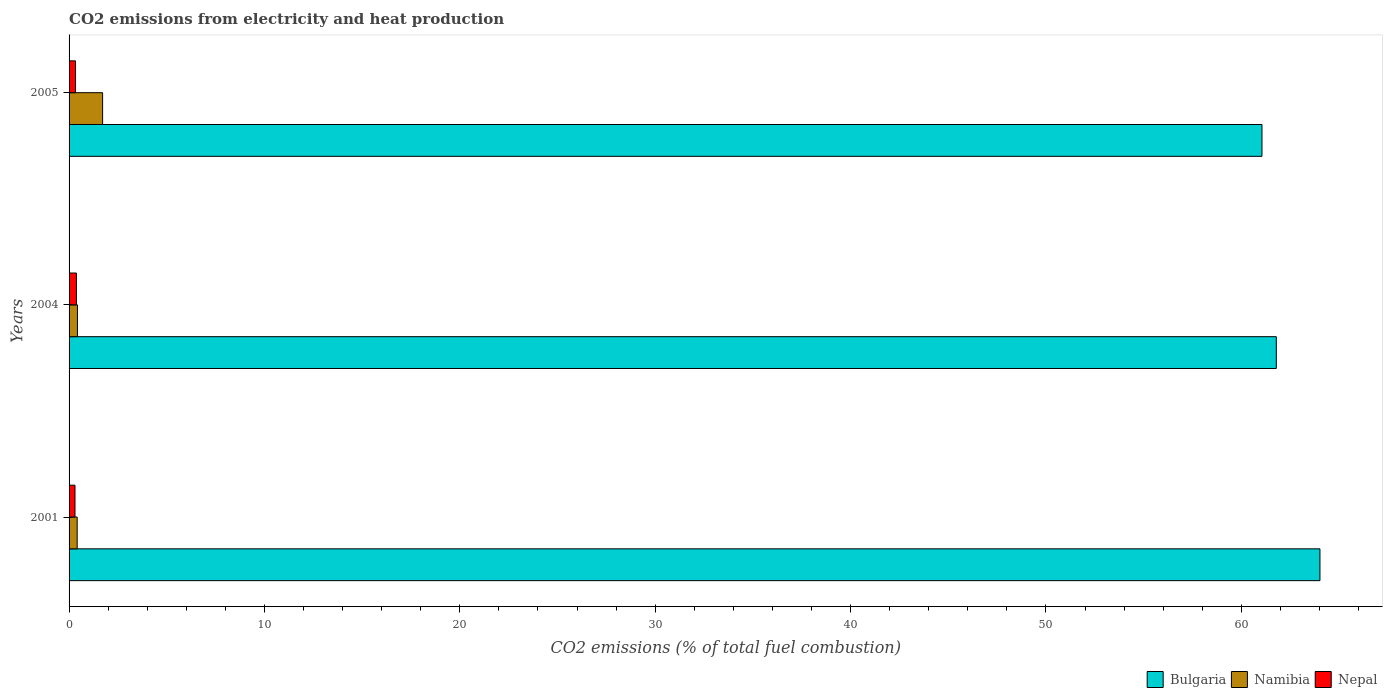How many bars are there on the 3rd tick from the top?
Your response must be concise. 3. What is the label of the 1st group of bars from the top?
Provide a succinct answer. 2005. In how many cases, is the number of bars for a given year not equal to the number of legend labels?
Offer a terse response. 0. What is the amount of CO2 emitted in Nepal in 2001?
Your response must be concise. 0.3. Across all years, what is the maximum amount of CO2 emitted in Nepal?
Your response must be concise. 0.38. Across all years, what is the minimum amount of CO2 emitted in Namibia?
Your response must be concise. 0.41. In which year was the amount of CO2 emitted in Bulgaria maximum?
Ensure brevity in your answer.  2001. In which year was the amount of CO2 emitted in Namibia minimum?
Your answer should be very brief. 2001. What is the total amount of CO2 emitted in Bulgaria in the graph?
Your answer should be very brief. 186.88. What is the difference between the amount of CO2 emitted in Bulgaria in 2001 and that in 2004?
Make the answer very short. 2.23. What is the difference between the amount of CO2 emitted in Namibia in 2004 and the amount of CO2 emitted in Bulgaria in 2001?
Give a very brief answer. -63.6. What is the average amount of CO2 emitted in Nepal per year?
Your answer should be very brief. 0.34. In the year 2005, what is the difference between the amount of CO2 emitted in Namibia and amount of CO2 emitted in Nepal?
Keep it short and to the point. 1.39. What is the ratio of the amount of CO2 emitted in Bulgaria in 2001 to that in 2004?
Your answer should be very brief. 1.04. What is the difference between the highest and the second highest amount of CO2 emitted in Namibia?
Your response must be concise. 1.29. What is the difference between the highest and the lowest amount of CO2 emitted in Bulgaria?
Your response must be concise. 2.97. In how many years, is the amount of CO2 emitted in Bulgaria greater than the average amount of CO2 emitted in Bulgaria taken over all years?
Keep it short and to the point. 1. How many bars are there?
Ensure brevity in your answer.  9. How many years are there in the graph?
Your answer should be compact. 3. Are the values on the major ticks of X-axis written in scientific E-notation?
Provide a short and direct response. No. Does the graph contain any zero values?
Your response must be concise. No. How many legend labels are there?
Your answer should be compact. 3. What is the title of the graph?
Your answer should be very brief. CO2 emissions from electricity and heat production. Does "Antigua and Barbuda" appear as one of the legend labels in the graph?
Offer a terse response. No. What is the label or title of the X-axis?
Provide a succinct answer. CO2 emissions (% of total fuel combustion). What is the label or title of the Y-axis?
Give a very brief answer. Years. What is the CO2 emissions (% of total fuel combustion) in Bulgaria in 2001?
Offer a very short reply. 64.03. What is the CO2 emissions (% of total fuel combustion) of Namibia in 2001?
Give a very brief answer. 0.41. What is the CO2 emissions (% of total fuel combustion) of Nepal in 2001?
Offer a very short reply. 0.3. What is the CO2 emissions (% of total fuel combustion) in Bulgaria in 2004?
Ensure brevity in your answer.  61.79. What is the CO2 emissions (% of total fuel combustion) of Namibia in 2004?
Give a very brief answer. 0.43. What is the CO2 emissions (% of total fuel combustion) of Nepal in 2004?
Your answer should be compact. 0.38. What is the CO2 emissions (% of total fuel combustion) of Bulgaria in 2005?
Your response must be concise. 61.06. What is the CO2 emissions (% of total fuel combustion) of Namibia in 2005?
Make the answer very short. 1.72. What is the CO2 emissions (% of total fuel combustion) in Nepal in 2005?
Offer a terse response. 0.33. Across all years, what is the maximum CO2 emissions (% of total fuel combustion) in Bulgaria?
Your answer should be very brief. 64.03. Across all years, what is the maximum CO2 emissions (% of total fuel combustion) in Namibia?
Your answer should be very brief. 1.72. Across all years, what is the maximum CO2 emissions (% of total fuel combustion) in Nepal?
Keep it short and to the point. 0.38. Across all years, what is the minimum CO2 emissions (% of total fuel combustion) of Bulgaria?
Provide a succinct answer. 61.06. Across all years, what is the minimum CO2 emissions (% of total fuel combustion) of Namibia?
Your response must be concise. 0.41. Across all years, what is the minimum CO2 emissions (% of total fuel combustion) in Nepal?
Provide a short and direct response. 0.3. What is the total CO2 emissions (% of total fuel combustion) in Bulgaria in the graph?
Keep it short and to the point. 186.88. What is the total CO2 emissions (% of total fuel combustion) of Namibia in the graph?
Provide a short and direct response. 2.56. What is the difference between the CO2 emissions (% of total fuel combustion) in Bulgaria in 2001 and that in 2004?
Your response must be concise. 2.23. What is the difference between the CO2 emissions (% of total fuel combustion) in Namibia in 2001 and that in 2004?
Provide a succinct answer. -0.01. What is the difference between the CO2 emissions (% of total fuel combustion) in Nepal in 2001 and that in 2004?
Keep it short and to the point. -0.07. What is the difference between the CO2 emissions (% of total fuel combustion) of Bulgaria in 2001 and that in 2005?
Offer a very short reply. 2.97. What is the difference between the CO2 emissions (% of total fuel combustion) in Namibia in 2001 and that in 2005?
Make the answer very short. -1.3. What is the difference between the CO2 emissions (% of total fuel combustion) in Nepal in 2001 and that in 2005?
Your answer should be compact. -0.03. What is the difference between the CO2 emissions (% of total fuel combustion) of Bulgaria in 2004 and that in 2005?
Make the answer very short. 0.73. What is the difference between the CO2 emissions (% of total fuel combustion) of Namibia in 2004 and that in 2005?
Provide a short and direct response. -1.29. What is the difference between the CO2 emissions (% of total fuel combustion) of Nepal in 2004 and that in 2005?
Your answer should be very brief. 0.05. What is the difference between the CO2 emissions (% of total fuel combustion) of Bulgaria in 2001 and the CO2 emissions (% of total fuel combustion) of Namibia in 2004?
Offer a terse response. 63.6. What is the difference between the CO2 emissions (% of total fuel combustion) in Bulgaria in 2001 and the CO2 emissions (% of total fuel combustion) in Nepal in 2004?
Offer a terse response. 63.65. What is the difference between the CO2 emissions (% of total fuel combustion) in Namibia in 2001 and the CO2 emissions (% of total fuel combustion) in Nepal in 2004?
Your answer should be very brief. 0.04. What is the difference between the CO2 emissions (% of total fuel combustion) of Bulgaria in 2001 and the CO2 emissions (% of total fuel combustion) of Namibia in 2005?
Offer a very short reply. 62.31. What is the difference between the CO2 emissions (% of total fuel combustion) in Bulgaria in 2001 and the CO2 emissions (% of total fuel combustion) in Nepal in 2005?
Offer a terse response. 63.7. What is the difference between the CO2 emissions (% of total fuel combustion) in Namibia in 2001 and the CO2 emissions (% of total fuel combustion) in Nepal in 2005?
Provide a succinct answer. 0.08. What is the difference between the CO2 emissions (% of total fuel combustion) in Bulgaria in 2004 and the CO2 emissions (% of total fuel combustion) in Namibia in 2005?
Give a very brief answer. 60.07. What is the difference between the CO2 emissions (% of total fuel combustion) of Bulgaria in 2004 and the CO2 emissions (% of total fuel combustion) of Nepal in 2005?
Make the answer very short. 61.46. What is the difference between the CO2 emissions (% of total fuel combustion) of Namibia in 2004 and the CO2 emissions (% of total fuel combustion) of Nepal in 2005?
Provide a short and direct response. 0.1. What is the average CO2 emissions (% of total fuel combustion) of Bulgaria per year?
Give a very brief answer. 62.29. What is the average CO2 emissions (% of total fuel combustion) in Namibia per year?
Offer a very short reply. 0.85. What is the average CO2 emissions (% of total fuel combustion) in Nepal per year?
Offer a very short reply. 0.34. In the year 2001, what is the difference between the CO2 emissions (% of total fuel combustion) of Bulgaria and CO2 emissions (% of total fuel combustion) of Namibia?
Keep it short and to the point. 63.61. In the year 2001, what is the difference between the CO2 emissions (% of total fuel combustion) of Bulgaria and CO2 emissions (% of total fuel combustion) of Nepal?
Provide a succinct answer. 63.72. In the year 2001, what is the difference between the CO2 emissions (% of total fuel combustion) of Namibia and CO2 emissions (% of total fuel combustion) of Nepal?
Your response must be concise. 0.11. In the year 2004, what is the difference between the CO2 emissions (% of total fuel combustion) in Bulgaria and CO2 emissions (% of total fuel combustion) in Namibia?
Keep it short and to the point. 61.36. In the year 2004, what is the difference between the CO2 emissions (% of total fuel combustion) in Bulgaria and CO2 emissions (% of total fuel combustion) in Nepal?
Your answer should be very brief. 61.42. In the year 2004, what is the difference between the CO2 emissions (% of total fuel combustion) in Namibia and CO2 emissions (% of total fuel combustion) in Nepal?
Your response must be concise. 0.05. In the year 2005, what is the difference between the CO2 emissions (% of total fuel combustion) of Bulgaria and CO2 emissions (% of total fuel combustion) of Namibia?
Ensure brevity in your answer.  59.34. In the year 2005, what is the difference between the CO2 emissions (% of total fuel combustion) of Bulgaria and CO2 emissions (% of total fuel combustion) of Nepal?
Give a very brief answer. 60.73. In the year 2005, what is the difference between the CO2 emissions (% of total fuel combustion) in Namibia and CO2 emissions (% of total fuel combustion) in Nepal?
Offer a very short reply. 1.39. What is the ratio of the CO2 emissions (% of total fuel combustion) in Bulgaria in 2001 to that in 2004?
Make the answer very short. 1.04. What is the ratio of the CO2 emissions (% of total fuel combustion) of Namibia in 2001 to that in 2004?
Provide a short and direct response. 0.97. What is the ratio of the CO2 emissions (% of total fuel combustion) of Nepal in 2001 to that in 2004?
Give a very brief answer. 0.81. What is the ratio of the CO2 emissions (% of total fuel combustion) of Bulgaria in 2001 to that in 2005?
Offer a very short reply. 1.05. What is the ratio of the CO2 emissions (% of total fuel combustion) of Namibia in 2001 to that in 2005?
Ensure brevity in your answer.  0.24. What is the ratio of the CO2 emissions (% of total fuel combustion) of Nepal in 2001 to that in 2005?
Offer a terse response. 0.92. What is the ratio of the CO2 emissions (% of total fuel combustion) in Bulgaria in 2004 to that in 2005?
Your response must be concise. 1.01. What is the ratio of the CO2 emissions (% of total fuel combustion) of Nepal in 2004 to that in 2005?
Provide a succinct answer. 1.14. What is the difference between the highest and the second highest CO2 emissions (% of total fuel combustion) of Bulgaria?
Your response must be concise. 2.23. What is the difference between the highest and the second highest CO2 emissions (% of total fuel combustion) of Namibia?
Provide a short and direct response. 1.29. What is the difference between the highest and the second highest CO2 emissions (% of total fuel combustion) in Nepal?
Your answer should be compact. 0.05. What is the difference between the highest and the lowest CO2 emissions (% of total fuel combustion) in Bulgaria?
Make the answer very short. 2.97. What is the difference between the highest and the lowest CO2 emissions (% of total fuel combustion) in Namibia?
Give a very brief answer. 1.3. What is the difference between the highest and the lowest CO2 emissions (% of total fuel combustion) in Nepal?
Provide a succinct answer. 0.07. 